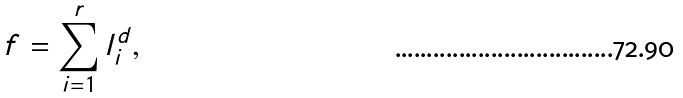Convert formula to latex. <formula><loc_0><loc_0><loc_500><loc_500>f = \sum _ { i = 1 } ^ { r } l _ { i } ^ { d } ,</formula> 